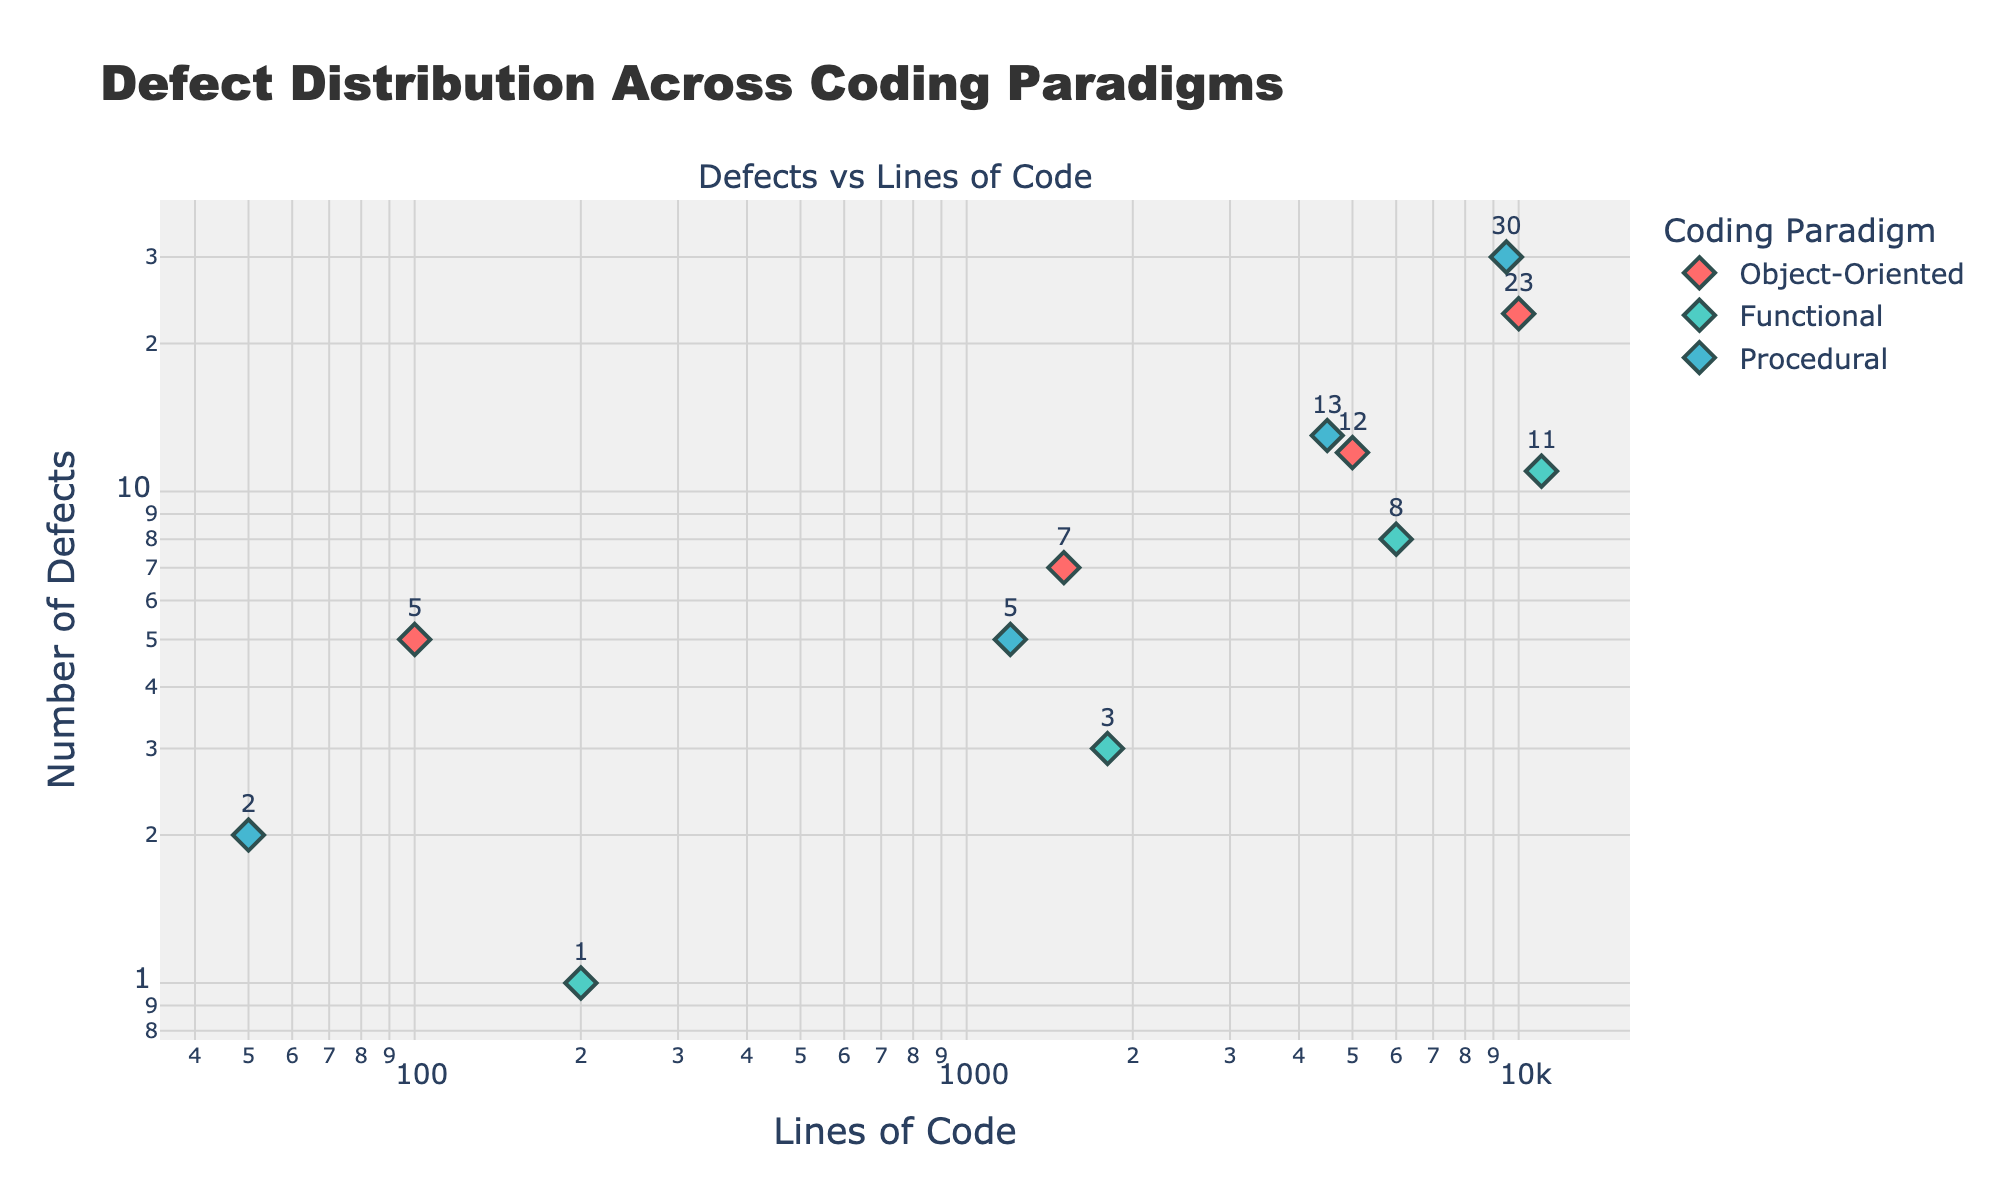What's the title of the plot? The title of the plot is displayed at the top of the figure.
Answer: Defect Distribution Across Coding Paradigms How many data points are represented for the functional paradigm? Count the number of markers specifically for the "Functional" paradigm.
Answer: 4 What is the highest number of defects in the procedural paradigm? Identify the data point with the highest y-value (number of defects) for the "Procedural" paradigm.
Answer: 30 Which coding paradigm has fewer defects for around 1000 lines of code? Compare the y-values (defects) for the "Object-Oriented," "Functional," and "Procedural" paradigms for x-values (lines of code) around 1000.
Answer: Functional What’s the average number of defects for data points in the object-oriented paradigm? Sum the number of defects for the "Object-Oriented" paradigm and divide by the number of data points. Calculation: (5 + 7 + 12 + 23)/4 = 47/4
Answer: 11.75 Which coding paradigm has the steepest increase in defects as lines of code increase? Observe the gradient/slope of the points for each paradigm to determine which one has the most rapid increase in defects.
Answer: Procedural For the "Functional" paradigm, compare the defects for lines of code at 200 and 11000. How many times more defects are present at 11000 lines of code compared to 200 lines? Compute the ratio of defects at 11000 lines of code to defects at 200 lines of code. Calculation: 11/1 = 11
Answer: 11 At roughly 5000 lines of code, which paradigm has the least number of defects? Compare the y-values (number of defects) around 5000 lines of code for each coding paradigm.
Answer: Functional Identify the general trend for defects as lines of code increase for the object-oriented paradigm. Observe the relationship between x-values (lines of code) and y-values (defects) for the "Object-Oriented" paradigm.
Answer: Increasing Which coding paradigm has the most spread (variance) in the number of defects across different lines of code ranges? Compare the spread of y-values (defects) across the x-axis (lines of code) for each paradigm.
Answer: Procedural 